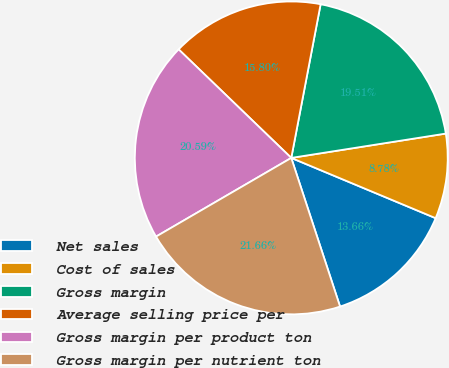<chart> <loc_0><loc_0><loc_500><loc_500><pie_chart><fcel>Net sales<fcel>Cost of sales<fcel>Gross margin<fcel>Average selling price per<fcel>Gross margin per product ton<fcel>Gross margin per nutrient ton<nl><fcel>13.66%<fcel>8.78%<fcel>19.51%<fcel>15.8%<fcel>20.59%<fcel>21.66%<nl></chart> 